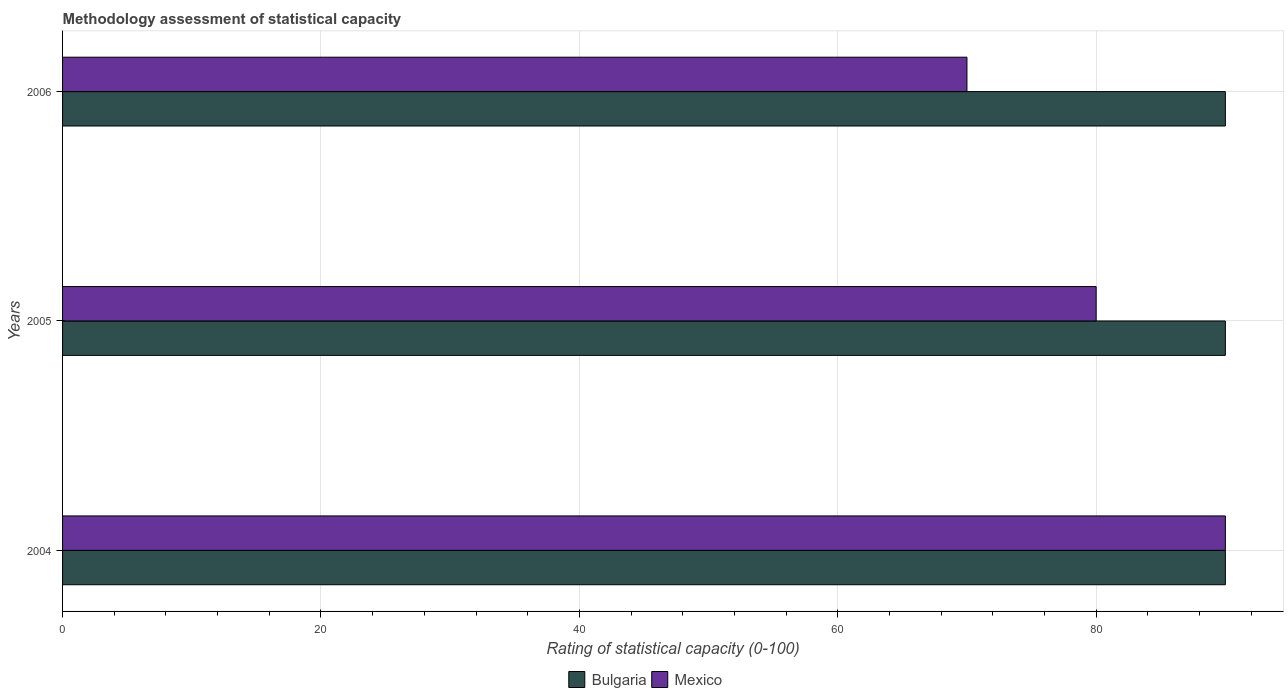How many groups of bars are there?
Give a very brief answer. 3. How many bars are there on the 2nd tick from the top?
Offer a very short reply. 2. How many bars are there on the 3rd tick from the bottom?
Ensure brevity in your answer.  2. What is the label of the 2nd group of bars from the top?
Provide a short and direct response. 2005. What is the rating of statistical capacity in Bulgaria in 2006?
Your answer should be compact. 90. Across all years, what is the maximum rating of statistical capacity in Mexico?
Keep it short and to the point. 90. Across all years, what is the minimum rating of statistical capacity in Bulgaria?
Your answer should be very brief. 90. In which year was the rating of statistical capacity in Bulgaria minimum?
Ensure brevity in your answer.  2004. What is the total rating of statistical capacity in Bulgaria in the graph?
Provide a short and direct response. 270. What is the difference between the rating of statistical capacity in Mexico in 2004 and that in 2005?
Give a very brief answer. 10. What is the difference between the rating of statistical capacity in Bulgaria in 2004 and the rating of statistical capacity in Mexico in 2005?
Keep it short and to the point. 10. In the year 2005, what is the difference between the rating of statistical capacity in Bulgaria and rating of statistical capacity in Mexico?
Offer a very short reply. 10. What is the ratio of the rating of statistical capacity in Mexico in 2004 to that in 2006?
Keep it short and to the point. 1.29. Is the rating of statistical capacity in Bulgaria in 2004 less than that in 2006?
Give a very brief answer. No. What is the difference between the highest and the second highest rating of statistical capacity in Bulgaria?
Your answer should be compact. 0. Is the sum of the rating of statistical capacity in Bulgaria in 2004 and 2005 greater than the maximum rating of statistical capacity in Mexico across all years?
Provide a succinct answer. Yes. What does the 2nd bar from the bottom in 2005 represents?
Offer a terse response. Mexico. Are all the bars in the graph horizontal?
Your answer should be compact. Yes. What is the difference between two consecutive major ticks on the X-axis?
Make the answer very short. 20. Does the graph contain any zero values?
Your answer should be compact. No. How are the legend labels stacked?
Give a very brief answer. Horizontal. What is the title of the graph?
Your answer should be very brief. Methodology assessment of statistical capacity. Does "United States" appear as one of the legend labels in the graph?
Ensure brevity in your answer.  No. What is the label or title of the X-axis?
Ensure brevity in your answer.  Rating of statistical capacity (0-100). What is the Rating of statistical capacity (0-100) of Mexico in 2004?
Make the answer very short. 90. What is the Rating of statistical capacity (0-100) of Bulgaria in 2005?
Your response must be concise. 90. Across all years, what is the maximum Rating of statistical capacity (0-100) of Bulgaria?
Give a very brief answer. 90. What is the total Rating of statistical capacity (0-100) in Bulgaria in the graph?
Provide a short and direct response. 270. What is the total Rating of statistical capacity (0-100) in Mexico in the graph?
Your answer should be very brief. 240. What is the difference between the Rating of statistical capacity (0-100) in Mexico in 2004 and that in 2005?
Offer a very short reply. 10. What is the difference between the Rating of statistical capacity (0-100) of Mexico in 2005 and that in 2006?
Your answer should be compact. 10. What is the difference between the Rating of statistical capacity (0-100) in Bulgaria in 2005 and the Rating of statistical capacity (0-100) in Mexico in 2006?
Give a very brief answer. 20. What is the average Rating of statistical capacity (0-100) of Bulgaria per year?
Keep it short and to the point. 90. What is the average Rating of statistical capacity (0-100) of Mexico per year?
Your response must be concise. 80. In the year 2005, what is the difference between the Rating of statistical capacity (0-100) in Bulgaria and Rating of statistical capacity (0-100) in Mexico?
Ensure brevity in your answer.  10. In the year 2006, what is the difference between the Rating of statistical capacity (0-100) in Bulgaria and Rating of statistical capacity (0-100) in Mexico?
Provide a succinct answer. 20. What is the ratio of the Rating of statistical capacity (0-100) of Bulgaria in 2004 to that in 2006?
Provide a short and direct response. 1. What is the ratio of the Rating of statistical capacity (0-100) of Bulgaria in 2005 to that in 2006?
Your response must be concise. 1. What is the ratio of the Rating of statistical capacity (0-100) of Mexico in 2005 to that in 2006?
Keep it short and to the point. 1.14. What is the difference between the highest and the second highest Rating of statistical capacity (0-100) in Mexico?
Offer a terse response. 10. 